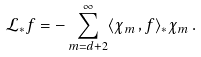<formula> <loc_0><loc_0><loc_500><loc_500>\mathcal { L } _ { \ast } { f } = - \sum _ { m = d + 2 } ^ { \infty } \langle \chi _ { m } \, , f \rangle _ { \ast } \chi _ { m } \, .</formula> 